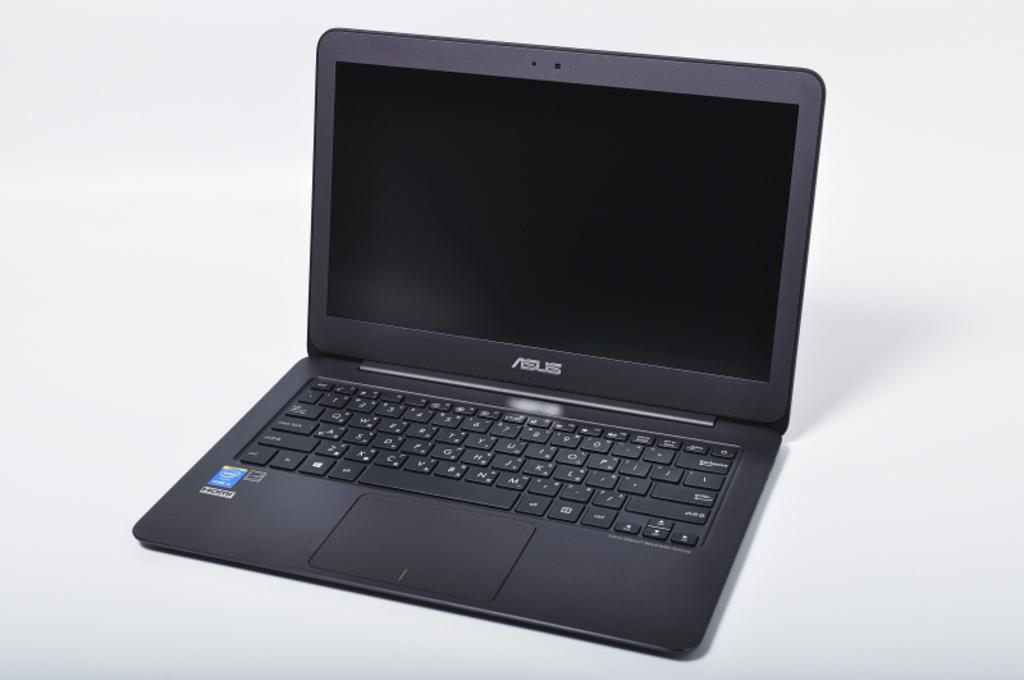<image>
Offer a succinct explanation of the picture presented. A black laptop with a keyboard that reads ASUS. 